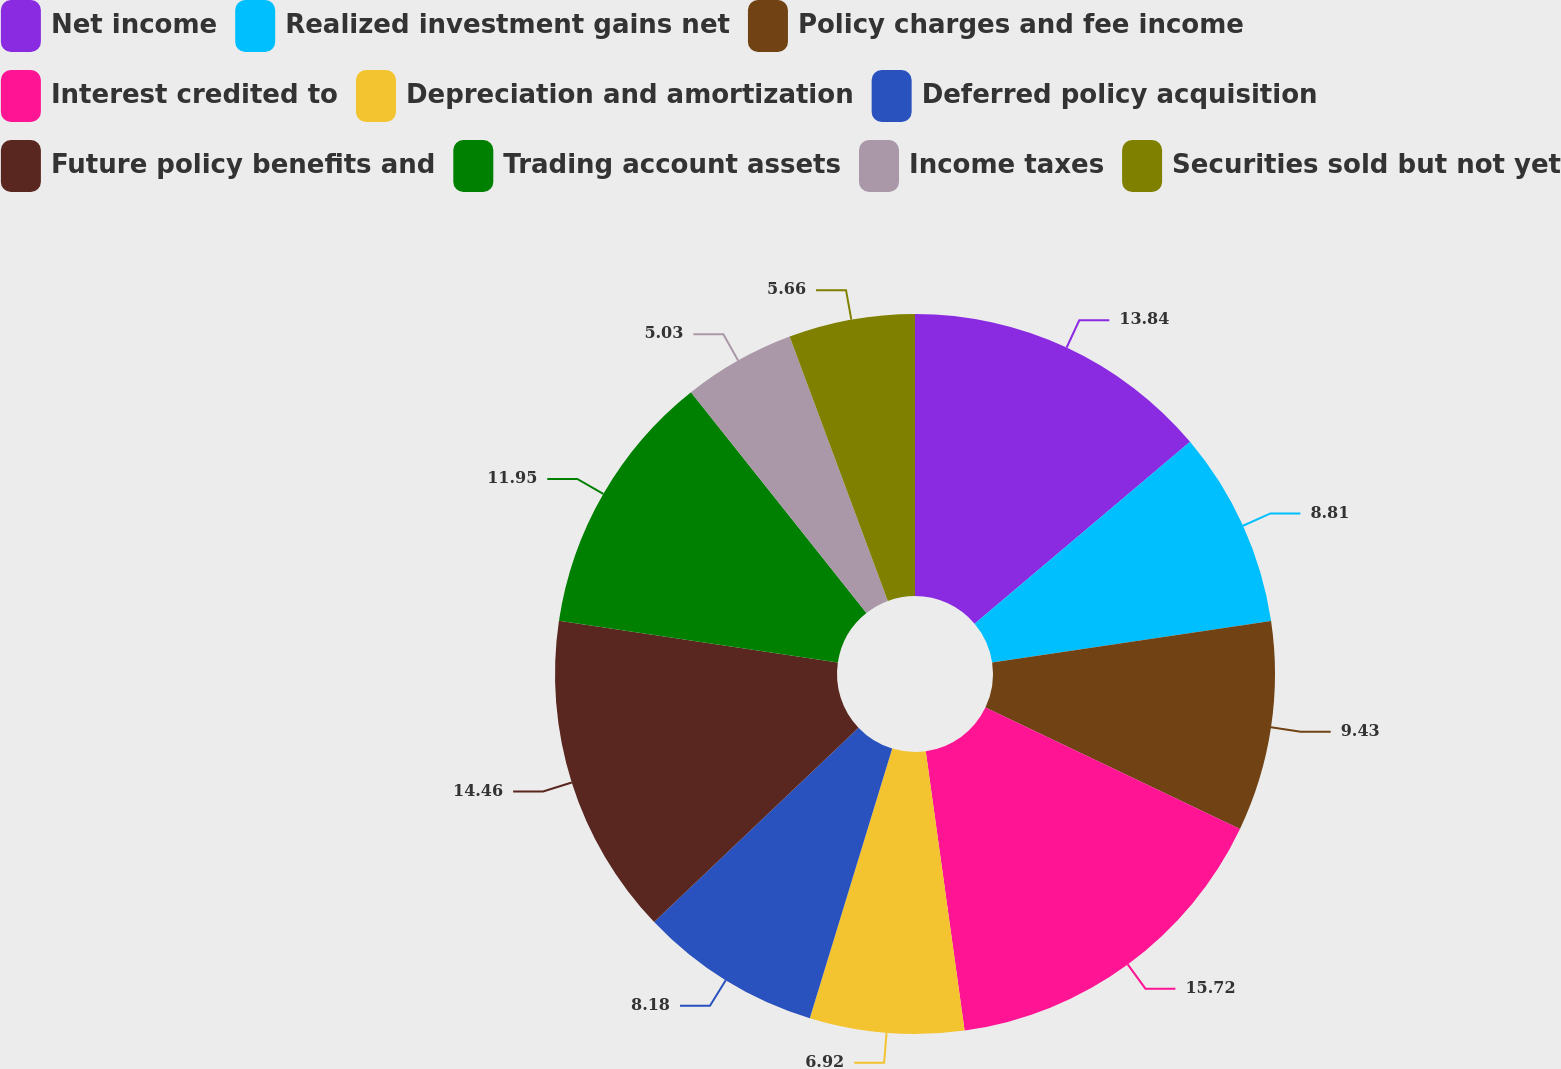Convert chart. <chart><loc_0><loc_0><loc_500><loc_500><pie_chart><fcel>Net income<fcel>Realized investment gains net<fcel>Policy charges and fee income<fcel>Interest credited to<fcel>Depreciation and amortization<fcel>Deferred policy acquisition<fcel>Future policy benefits and<fcel>Trading account assets<fcel>Income taxes<fcel>Securities sold but not yet<nl><fcel>13.84%<fcel>8.81%<fcel>9.43%<fcel>15.72%<fcel>6.92%<fcel>8.18%<fcel>14.46%<fcel>11.95%<fcel>5.03%<fcel>5.66%<nl></chart> 